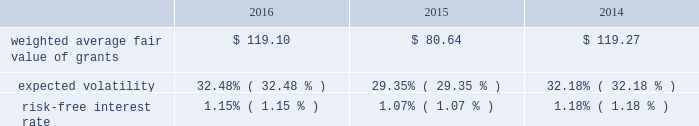Weighted average fair values and valuation assumptions used to value performance unit and performance stock grants during the years ended december 31 , 2016 , 2015 and 2014 were as follows: .
Expected volatility is based on the term-matched historical volatility over the simulated term , which is calculated as the time between the grant date and the end of the performance period .
The risk-free interest rate is based on a 3.25 year zero-coupon risk-free interest rate derived from the treasury constant maturities yield curve on the grant date .
At december 31 , 2016 , unrecognized compensation expense related to performance units totaled $ 10 million .
Such unrecognized expense will be amortized on a straight-line basis over a weighted average period of 3.0 years .
Pension plans .
Eog has a defined contribution pension plan in place for most of its employees in the united states .
Eog's contributions to the pension plan are based on various percentages of compensation and , in some instances , are based upon the amount of the employees' contributions .
Eog's total costs recognized for the plan were $ 34 million , $ 36 million and $ 41 million for 2016 , 2015 and 2014 , respectively .
In addition , eog's trinidadian subsidiary maintains a contributory defined benefit pension plan and a matched savings plan .
Eog's united kingdom subsidiary maintains a pension plan which includes a non-contributory defined contribution pension plan and a matched defined contribution savings plan .
These pension plans are available to most employees of the trinidadian and united kingdom subsidiaries .
Eog's combined contributions to these plans were $ 1 million , $ 1 million and $ 5 million for 2016 , 2015 and 2014 , respectively .
For the trinidadian defined benefit pension plan , the benefit obligation , fair value of plan assets and accrued benefit cost totaled $ 8 million , $ 7 million and $ 0.3 million , respectively , at december 31 , 2016 , and $ 9 million , $ 7 million and $ 0.2 million , respectively , at december 31 , 2015 .
In connection with the divestiture of substantially all of its canadian assets in the fourth quarter of 2014 , eog has elected to terminate the canadian non-contributory defined benefit pension plan .
Postretirement health care .
Eog has postretirement medical and dental benefits in place for eligible united states and trinidad employees and their eligible dependents , the costs of which are not material .
Commitments and contingencies letters of credit and guarantees .
At december 31 , 2016 and 2015 , respectively , eog had standby letters of credit and guarantees outstanding totaling approximately $ 226 million and $ 272 million , primarily representing guarantees of payment or performance obligations on behalf of subsidiaries .
As of february 20 , 2017 , there were no demands for payment under these guarantees. .
Considering the years 2014-2016 , what is the average expected volatility? 
Rationale: it is the sum of all percentages of expected volatility divided by three .
Computations: table_average(expected volatility, none)
Answer: 0.31337. 